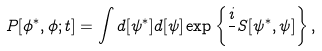<formula> <loc_0><loc_0><loc_500><loc_500>P [ \phi ^ { * } , \phi ; t ] = \int d [ \psi ^ { * } ] d [ \psi ] \exp \left \{ \frac { i } { } S [ \psi ^ { * } , \psi ] \right \} ,</formula> 